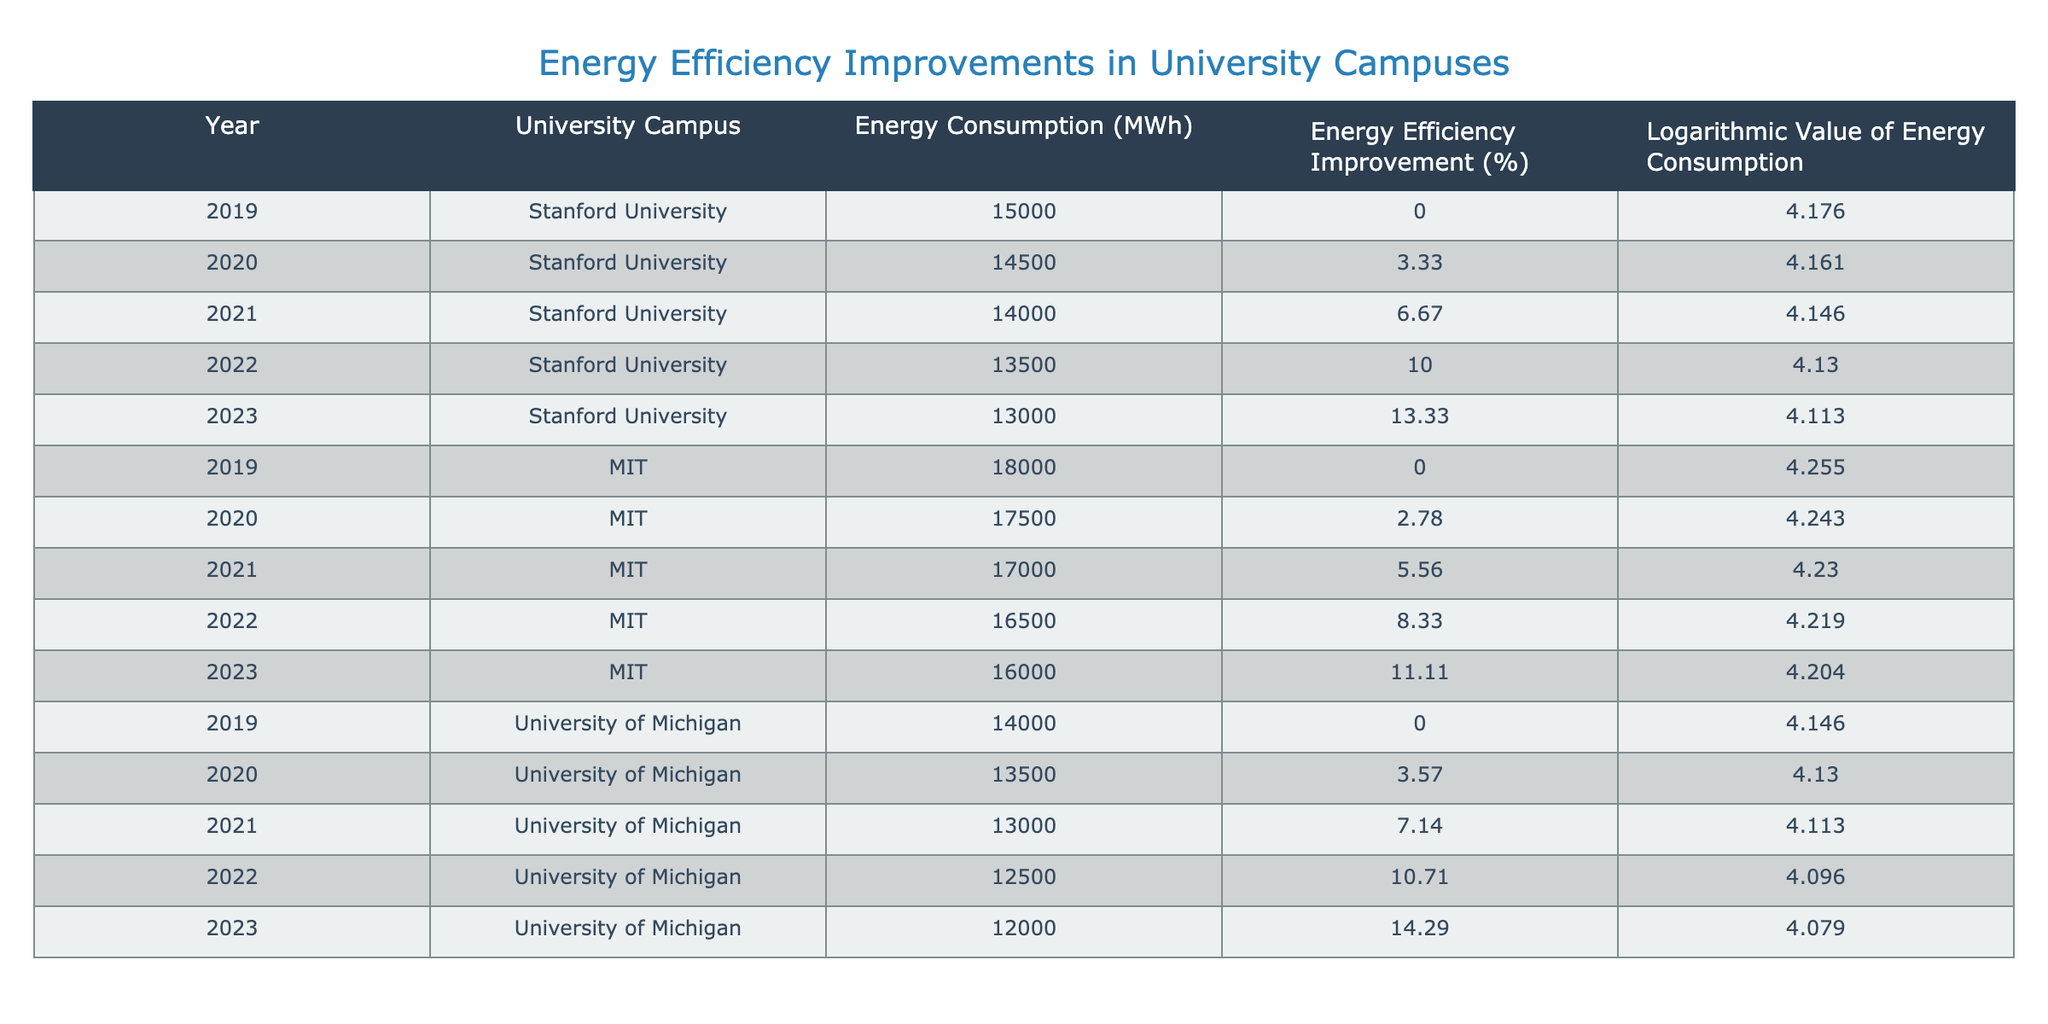What was the energy consumption of Stanford University in 2021? According to the table, the energy consumption for Stanford University in 2021 is stated in the respective year row. The value is 14000 MWh.
Answer: 14000 MWh Which university showed the highest energy consumption in 2019? By comparing the energy consumption values in the year 2019 for each university, MIT has the highest value at 18000 MWh.
Answer: MIT What is the percentage improvement in energy efficiency for the University of Michigan from 2019 to 2023? To find the improvement, we look at the energy efficiency improvement for 2019, which is 0%, and for 2023, which is 14.29%. The difference is 14.29% - 0% = 14.29%.
Answer: 14.29% What was the average logarithmic value of energy consumption for MIT from 2019 to 2023? First, we list the logarithmic values for MIT: 4.255, 4.243, 4.230, 4.219, and 4.204. We sum these values: 4.255 + 4.243 + 4.230 + 4.219 + 4.204 = 21.151, and then divide by 5 to find the average: 21.151 / 5 = 4.2302.
Answer: 4.2302 Did Stanford University achieve more than a 10% improvement in energy efficiency by 2022? The improvement in energy efficiency for Stanford University by 2022 is 10%. Since the question asks if it is more than 10%, the answer is no.
Answer: No What is the difference in energy efficiency improvement between the University of Michigan and MIT in 2022? The University of Michigan's energy efficiency improvement is 10.71% for 2022, while MIT's is 8.33%. The difference is 10.71% - 8.33% = 2.38%.
Answer: 2.38% Which university had the lowest energy consumption in 2022? By comparing the energy consumption figures for 2022, the lowest value is from the University of Michigan at 12500 MWh.
Answer: University of Michigan What was the logarithmic value of energy consumption for the University of Michigan in 2020? The table shows that the logarithmic value of energy consumption for the University of Michigan in 2020 is 4.130.
Answer: 4.130 